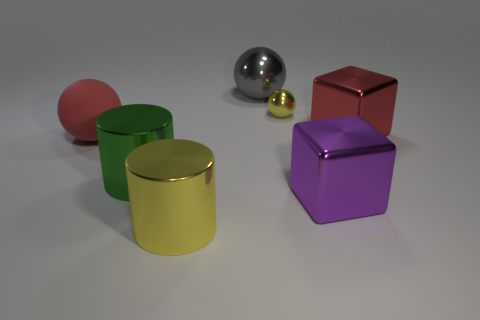Are the gray object and the red sphere made of the same material?
Provide a succinct answer. No. Are there more metal objects right of the red metallic object than big red metal cubes?
Ensure brevity in your answer.  No. How many objects are either gray metal objects or large gray objects that are behind the purple block?
Ensure brevity in your answer.  1. Are there more large gray metal balls in front of the large gray shiny object than yellow things that are left of the big green object?
Provide a short and direct response. No. There is a sphere on the left side of the cylinder in front of the metallic cylinder that is behind the yellow metal cylinder; what is its material?
Ensure brevity in your answer.  Rubber. There is a green object that is the same material as the yellow sphere; what shape is it?
Your response must be concise. Cylinder. There is a large object to the left of the green cylinder; is there a large metal thing that is in front of it?
Make the answer very short. Yes. The gray ball has what size?
Your answer should be very brief. Large. How many things are either purple shiny cubes or big green matte spheres?
Make the answer very short. 1. Is the yellow object that is behind the large red block made of the same material as the sphere that is in front of the yellow metallic sphere?
Give a very brief answer. No. 